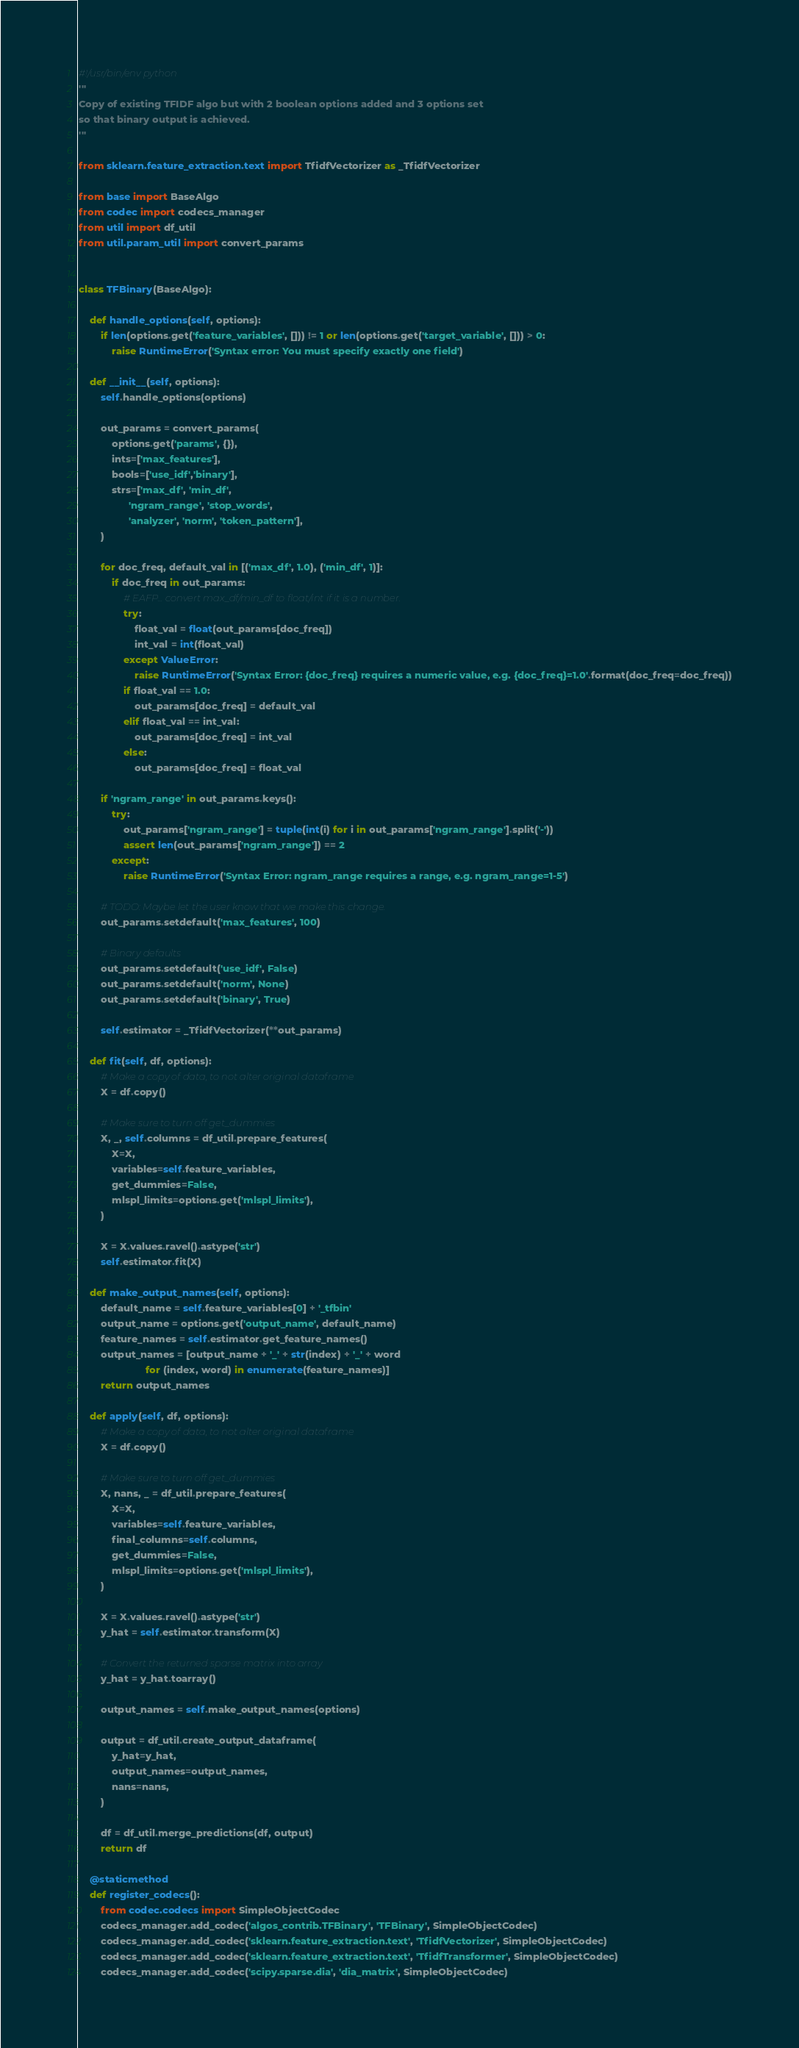Convert code to text. <code><loc_0><loc_0><loc_500><loc_500><_Python_>#!/usr/bin/env python
'''
Copy of existing TFIDF algo but with 2 boolean options added and 3 options set
so that binary output is achieved.
'''

from sklearn.feature_extraction.text import TfidfVectorizer as _TfidfVectorizer

from base import BaseAlgo
from codec import codecs_manager
from util import df_util
from util.param_util import convert_params


class TFBinary(BaseAlgo):

    def handle_options(self, options):
        if len(options.get('feature_variables', [])) != 1 or len(options.get('target_variable', [])) > 0:
            raise RuntimeError('Syntax error: You must specify exactly one field')

    def __init__(self, options):
        self.handle_options(options)

        out_params = convert_params(
            options.get('params', {}),
            ints=['max_features'],
            bools=['use_idf','binary'],
            strs=['max_df', 'min_df',
                  'ngram_range', 'stop_words',
                  'analyzer', 'norm', 'token_pattern'],
        )

        for doc_freq, default_val in [('max_df', 1.0), ('min_df', 1)]:
            if doc_freq in out_params:
                # EAFP... convert max_df/min_df to float/int if it is a number.
                try:
                    float_val = float(out_params[doc_freq])
                    int_val = int(float_val)
                except ValueError:
                    raise RuntimeError('Syntax Error: {doc_freq} requires a numeric value, e.g. {doc_freq}=1.0'.format(doc_freq=doc_freq))
                if float_val == 1.0:
                    out_params[doc_freq] = default_val
                elif float_val == int_val:
                    out_params[doc_freq] = int_val
                else:
                    out_params[doc_freq] = float_val

        if 'ngram_range' in out_params.keys():
            try:
                out_params['ngram_range'] = tuple(int(i) for i in out_params['ngram_range'].split('-'))
                assert len(out_params['ngram_range']) == 2
            except:
                raise RuntimeError('Syntax Error: ngram_range requires a range, e.g. ngram_range=1-5')

        # TODO: Maybe let the user know that we make this change.
        out_params.setdefault('max_features', 100)

        # Binary defaults
        out_params.setdefault('use_idf', False)
        out_params.setdefault('norm', None)
        out_params.setdefault('binary', True)

        self.estimator = _TfidfVectorizer(**out_params)

    def fit(self, df, options):
        # Make a copy of data, to not alter original dataframe
        X = df.copy()

        # Make sure to turn off get_dummies
        X, _, self.columns = df_util.prepare_features(
            X=X,
            variables=self.feature_variables,
            get_dummies=False,
            mlspl_limits=options.get('mlspl_limits'),
        )

        X = X.values.ravel().astype('str')
        self.estimator.fit(X)

    def make_output_names(self, options):
        default_name = self.feature_variables[0] + '_tfbin'
        output_name = options.get('output_name', default_name)
        feature_names = self.estimator.get_feature_names()
        output_names = [output_name + '_' + str(index) + '_' + word
                        for (index, word) in enumerate(feature_names)]
        return output_names

    def apply(self, df, options):
        # Make a copy of data, to not alter original dataframe
        X = df.copy()

        # Make sure to turn off get_dummies
        X, nans, _ = df_util.prepare_features(
            X=X,
            variables=self.feature_variables,
            final_columns=self.columns,
            get_dummies=False,
            mlspl_limits=options.get('mlspl_limits'),
        )

        X = X.values.ravel().astype('str')
        y_hat = self.estimator.transform(X)

        # Convert the returned sparse matrix into array
        y_hat = y_hat.toarray()

        output_names = self.make_output_names(options)

        output = df_util.create_output_dataframe(
            y_hat=y_hat,
            output_names=output_names,
            nans=nans,
        )

        df = df_util.merge_predictions(df, output)
        return df

    @staticmethod
    def register_codecs():
        from codec.codecs import SimpleObjectCodec
        codecs_manager.add_codec('algos_contrib.TFBinary', 'TFBinary', SimpleObjectCodec)
        codecs_manager.add_codec('sklearn.feature_extraction.text', 'TfidfVectorizer', SimpleObjectCodec)
        codecs_manager.add_codec('sklearn.feature_extraction.text', 'TfidfTransformer', SimpleObjectCodec)
        codecs_manager.add_codec('scipy.sparse.dia', 'dia_matrix', SimpleObjectCodec)
</code> 